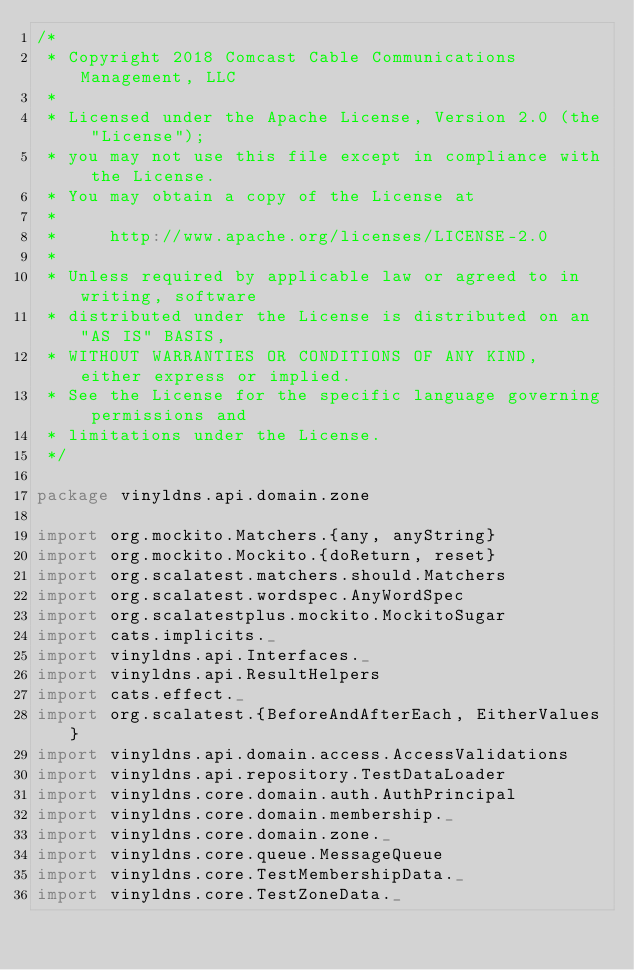<code> <loc_0><loc_0><loc_500><loc_500><_Scala_>/*
 * Copyright 2018 Comcast Cable Communications Management, LLC
 *
 * Licensed under the Apache License, Version 2.0 (the "License");
 * you may not use this file except in compliance with the License.
 * You may obtain a copy of the License at
 *
 *     http://www.apache.org/licenses/LICENSE-2.0
 *
 * Unless required by applicable law or agreed to in writing, software
 * distributed under the License is distributed on an "AS IS" BASIS,
 * WITHOUT WARRANTIES OR CONDITIONS OF ANY KIND, either express or implied.
 * See the License for the specific language governing permissions and
 * limitations under the License.
 */

package vinyldns.api.domain.zone

import org.mockito.Matchers.{any, anyString}
import org.mockito.Mockito.{doReturn, reset}
import org.scalatest.matchers.should.Matchers
import org.scalatest.wordspec.AnyWordSpec
import org.scalatestplus.mockito.MockitoSugar
import cats.implicits._
import vinyldns.api.Interfaces._
import vinyldns.api.ResultHelpers
import cats.effect._
import org.scalatest.{BeforeAndAfterEach, EitherValues}
import vinyldns.api.domain.access.AccessValidations
import vinyldns.api.repository.TestDataLoader
import vinyldns.core.domain.auth.AuthPrincipal
import vinyldns.core.domain.membership._
import vinyldns.core.domain.zone._
import vinyldns.core.queue.MessageQueue
import vinyldns.core.TestMembershipData._
import vinyldns.core.TestZoneData._</code> 